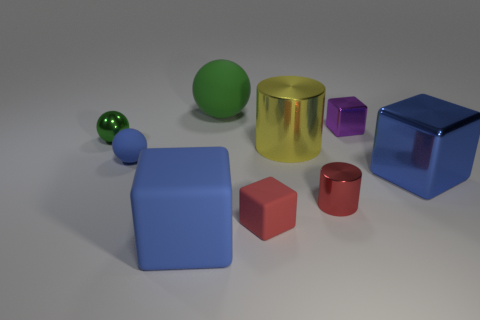There is a tiny metal cylinder; is it the same color as the small cube that is in front of the purple shiny cube?
Offer a very short reply. Yes. What is the material of the big thing that is on the left side of the tiny red rubber cube and in front of the shiny sphere?
Offer a very short reply. Rubber. There is a large thing that is the same shape as the tiny blue rubber object; what material is it?
Your answer should be very brief. Rubber. There is a large blue shiny cube that is right of the shiny cylinder to the right of the big yellow metal thing; what number of blue things are behind it?
Your response must be concise. 1. Is there any other thing that is the same color as the large matte block?
Offer a terse response. Yes. What number of blue things are in front of the tiny red matte object and to the right of the big cylinder?
Your answer should be very brief. 0. Is the size of the cube left of the green rubber ball the same as the red object that is right of the red rubber thing?
Provide a short and direct response. No. What number of things are metallic blocks in front of the small purple block or shiny blocks?
Your response must be concise. 2. What is the large blue cube left of the big green rubber thing made of?
Give a very brief answer. Rubber. What is the small red cylinder made of?
Your response must be concise. Metal. 